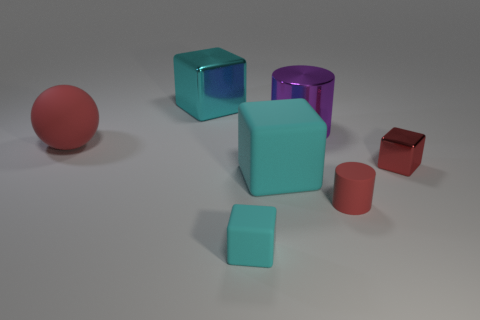Add 3 big cylinders. How many objects exist? 10 Subtract all cyan blocks. How many blocks are left? 1 Subtract all blocks. How many objects are left? 3 Subtract all purple cylinders. How many cylinders are left? 1 Subtract 1 cylinders. How many cylinders are left? 1 Add 1 small purple matte cylinders. How many small purple matte cylinders exist? 1 Subtract 0 gray cubes. How many objects are left? 7 Subtract all purple cylinders. Subtract all cyan spheres. How many cylinders are left? 1 Subtract all green cylinders. How many cyan cubes are left? 3 Subtract all cyan metallic blocks. Subtract all red metal cubes. How many objects are left? 5 